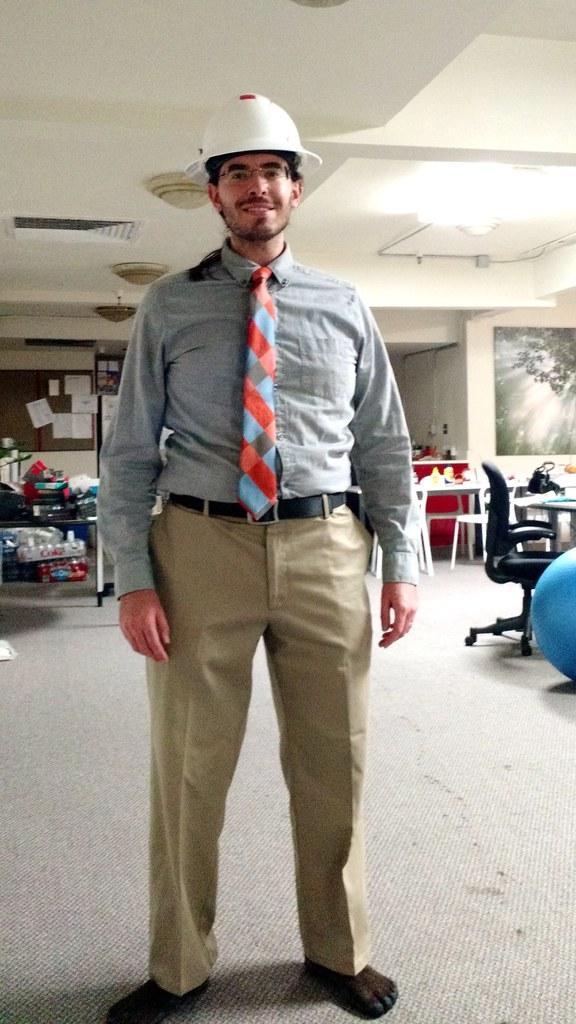Could you give a brief overview of what you see in this image? In this picture there is a man who is standing in the center of the image and there are chairs on the right side of the image. 